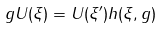Convert formula to latex. <formula><loc_0><loc_0><loc_500><loc_500>g U ( \xi ) = U ( \xi ^ { \prime } ) h ( \xi , g )</formula> 